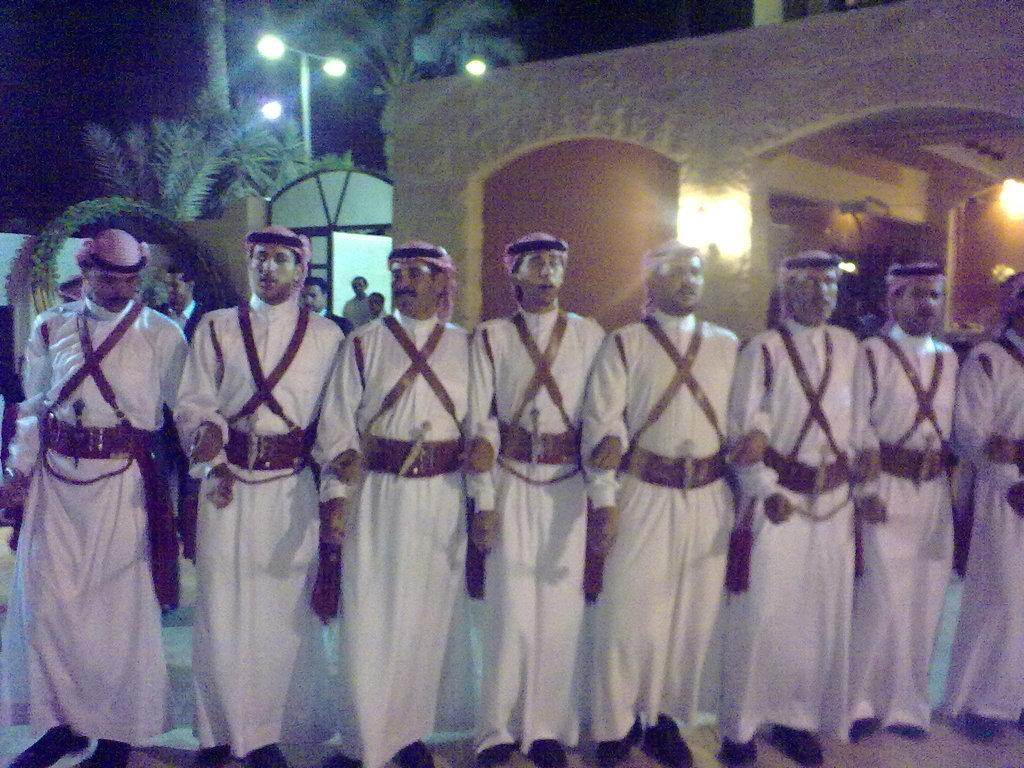What can be seen in the image? There is a group of men in the image. What are the men wearing? The men are wearing white color Arabian traditional dress. What are the men doing in the image? The men are standing and singing. What can be seen in the background of the image? There is a brown color arch and coconut trees in the background. What type of thread is being used by the flock of zephyrs in the image? There are no zephyrs or thread present in the image. Zephyrs are gentle winds, and they do not use thread. 